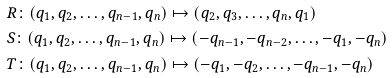Convert formula to latex. <formula><loc_0><loc_0><loc_500><loc_500>& R \colon ( q _ { 1 } , q _ { 2 } , \dots , q _ { n - 1 } , q _ { n } ) \mapsto ( q _ { 2 } , q _ { 3 } , \dots , q _ { n } , q _ { 1 } ) \\ & S \colon ( q _ { 1 } , q _ { 2 } , \dots , q _ { n - 1 } , q _ { n } ) \mapsto ( - q _ { n - 1 } , - q _ { n - 2 } , \dots , - q _ { 1 } , - q _ { n } ) \\ & T \colon ( q _ { 1 } , q _ { 2 } , \dots , q _ { n - 1 } , q _ { n } ) \mapsto ( - q _ { 1 } , - q _ { 2 } , \dots , - q _ { n - 1 } , - q _ { n } )</formula> 